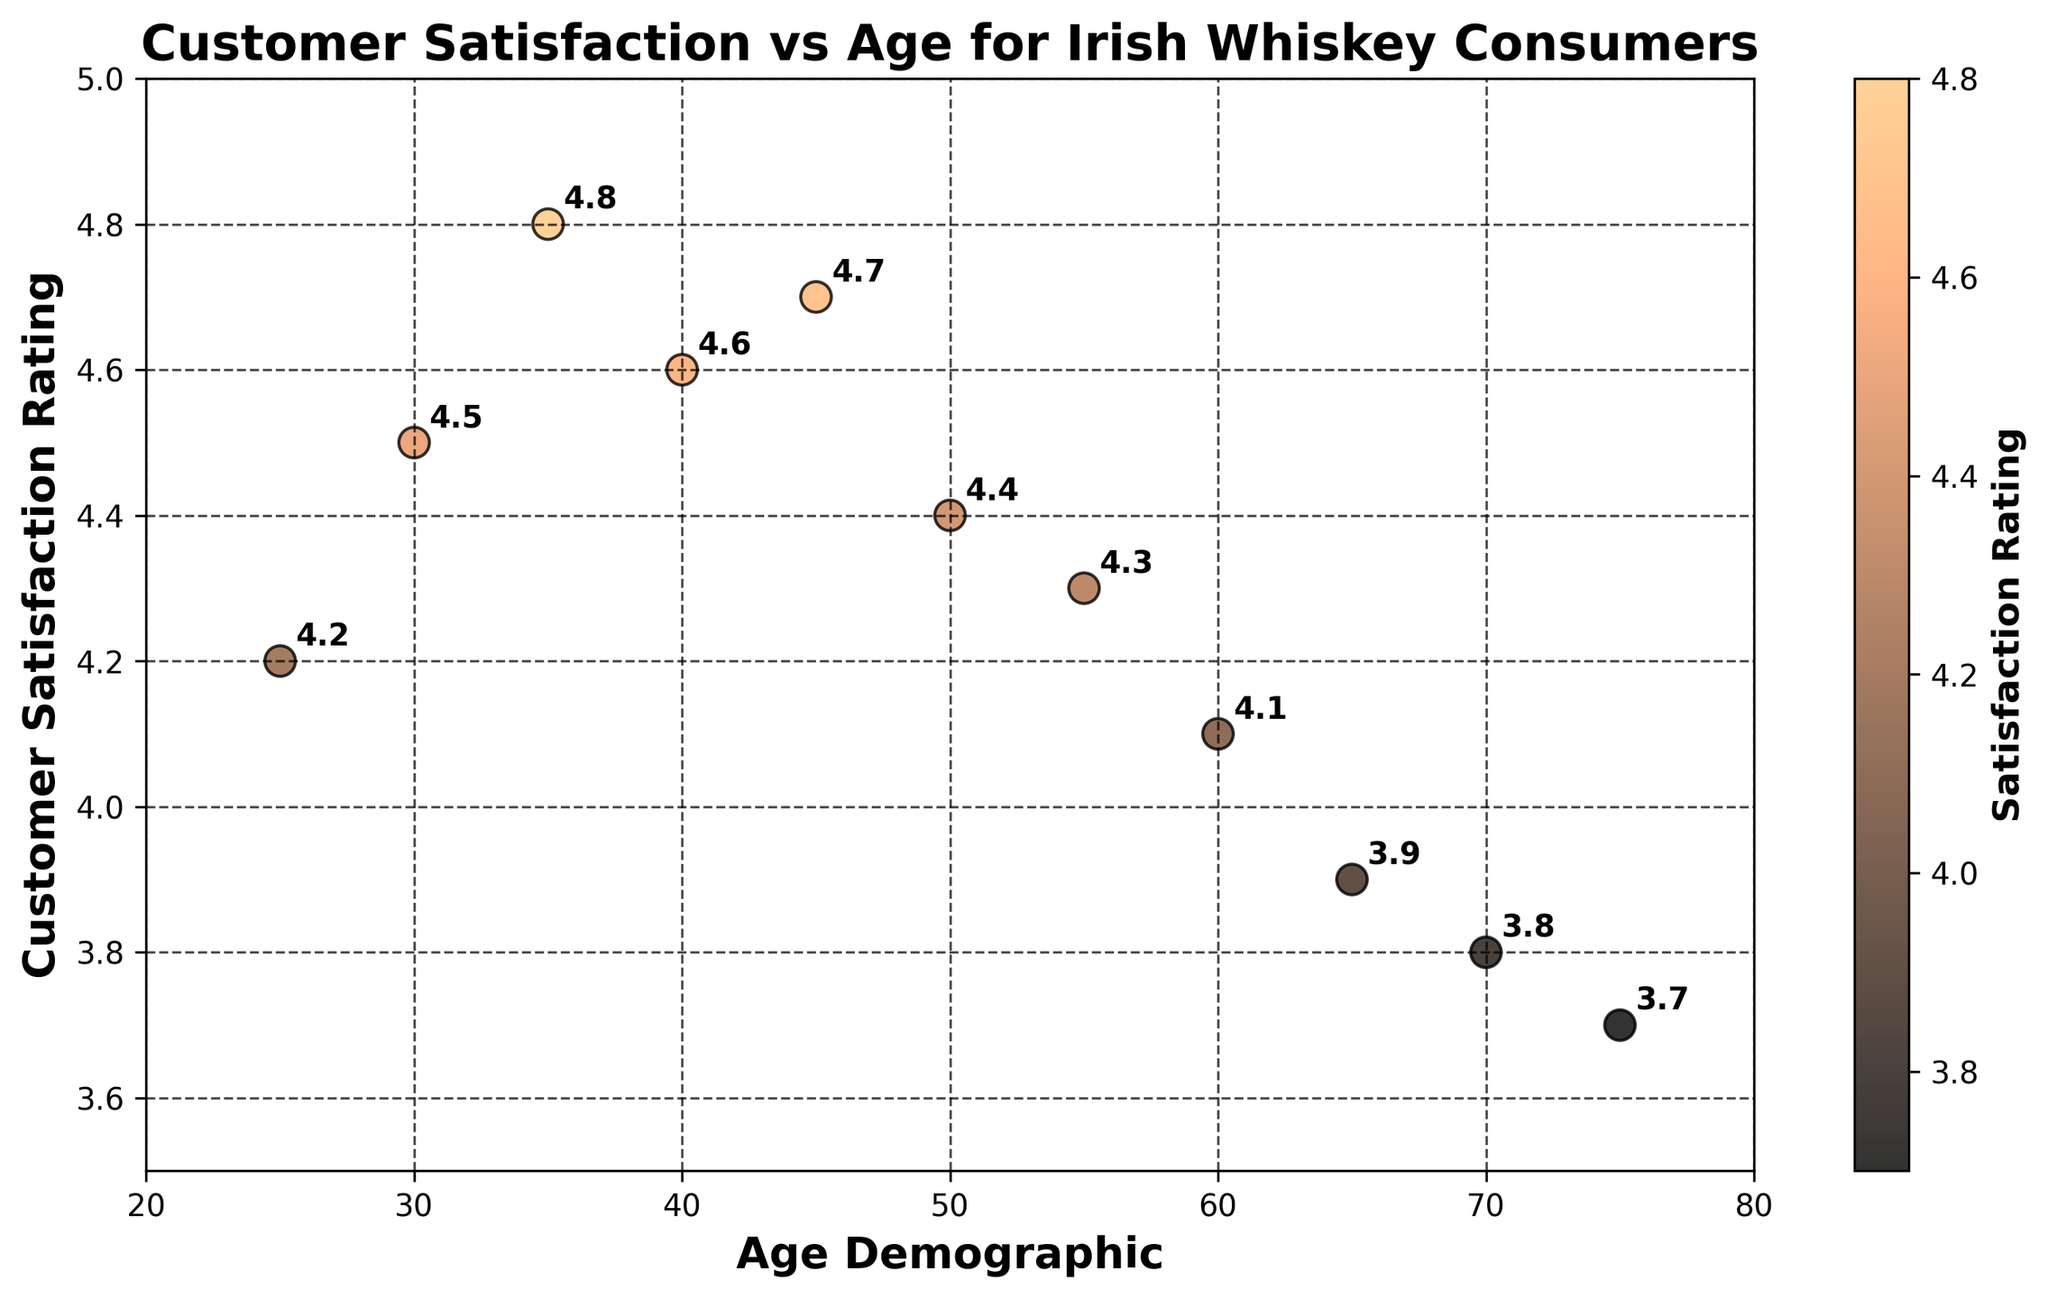What is the title of the scatter plot? The title is displayed at the top of the scatter plot. It reads 'Customer Satisfaction vs Age for Irish Whiskey Consumers'.
Answer: Customer Satisfaction vs Age for Irish Whiskey Consumers What is the age demographic range shown in the scatter plot? The x-axis indicates the age demographic, which ranges from 20 to 80 years old. This can be seen from the axis labels.
Answer: 20 to 80 years old How many data points are plotted on the scatter plot? Each point corresponds to a customer satisfaction rating for a specific age demographic. Counting these points gives a total of 11 data points.
Answer: 11 What is the customer satisfaction rating for the 50-year-olds? Looking at the point corresponding to the age 50 on the x-axis, the annotated label near this point indicates a satisfaction rating of 4.4.
Answer: 4.4 What age group has the lowest customer satisfaction rating, and what is it? By examining the points on the lower end of the y-axis, we find that the 75-year-olds have the lowest satisfaction rating of 3.7.
Answer: 75 years old, 3.7 What is the difference in customer satisfaction rating between 35-year-olds and 60-year-olds? The rating for 35-year-olds is 4.8, and for 60-year-olds, it is 4.1. The difference is 4.8 - 4.1 = 0.7.
Answer: 0.7 Which age group has the highest customer satisfaction rating? By looking at the y-axis and finding the highest point, the 35-year-olds have the highest satisfaction rating of 4.8.
Answer: 35 years old How does customer satisfaction change with increasing age? Observing the trend from left to right (lower to higher ages), customer satisfaction tends to increase up to around 35, then gradually decreases.
Answer: Increases, then decreases What is the average customer satisfaction rating across all age demographics? Sum of ratings: 4.2 + 4.5 + 4.8 + 4.6 + 4.7 + 4.4 + 4.3 + 4.1 + 3.9 + 3.8 + 3.7 = 47.0. Average = 47.0 / 11 ≈ 4.27.
Answer: 4.27 What can be said about the distribution of satisfaction ratings for the age groups between 30 and 50 years old? The ratings for age groups 30, 35, 40, 45, and 50 are 4.5, 4.8, 4.6, 4.7, and 4.4, respectively, which are all relatively high and above 4.4.
Answer: Generally high ratings 